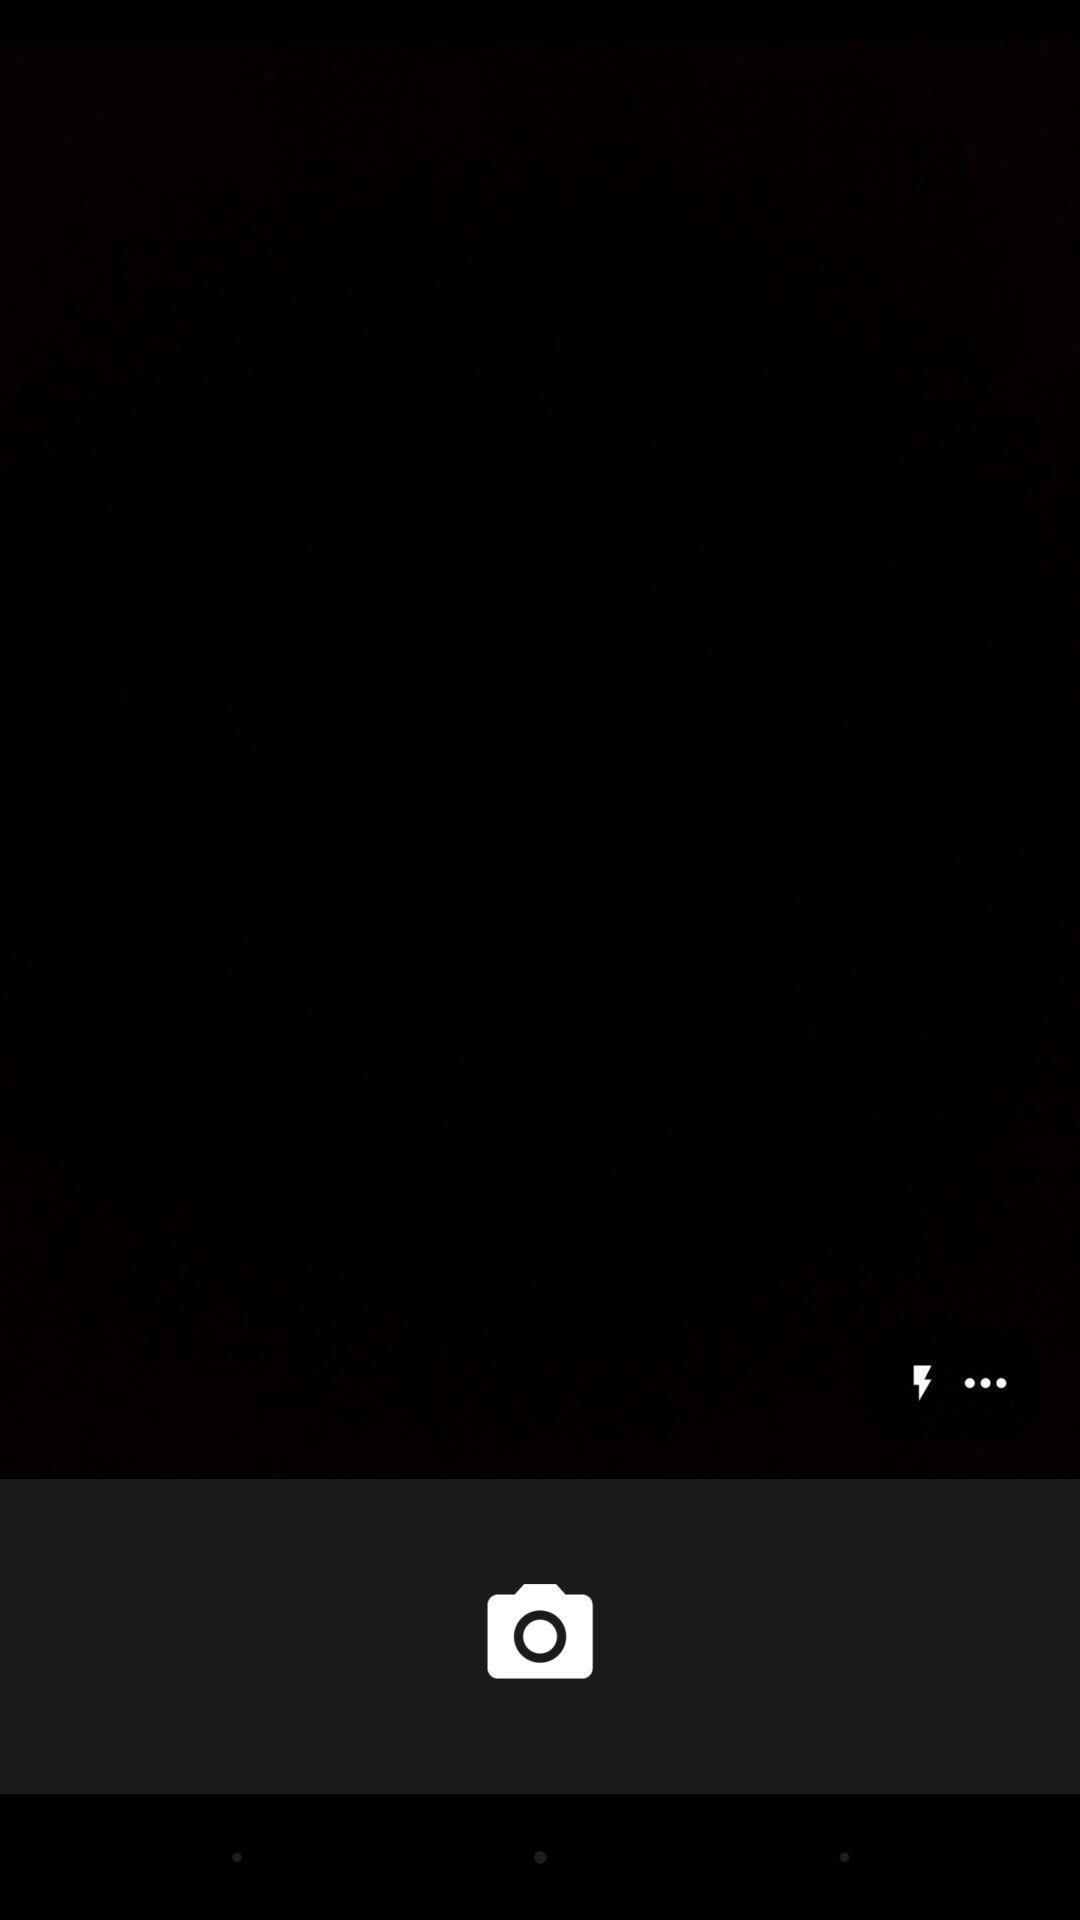Provide a detailed account of this screenshot. Page displaying to take a picture. 